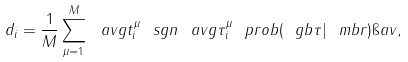Convert formula to latex. <formula><loc_0><loc_0><loc_500><loc_500>d _ { i } = \frac { 1 } { M } \sum _ { \mu = 1 } ^ { M } \ a v g { t _ { i } ^ { \mu } \ s g n \ a v g { \tau _ { i } ^ { \mu } } { \ p r o b ( \ g b { \tau } | \ m b { r } ) } } { \i a v } ,</formula> 